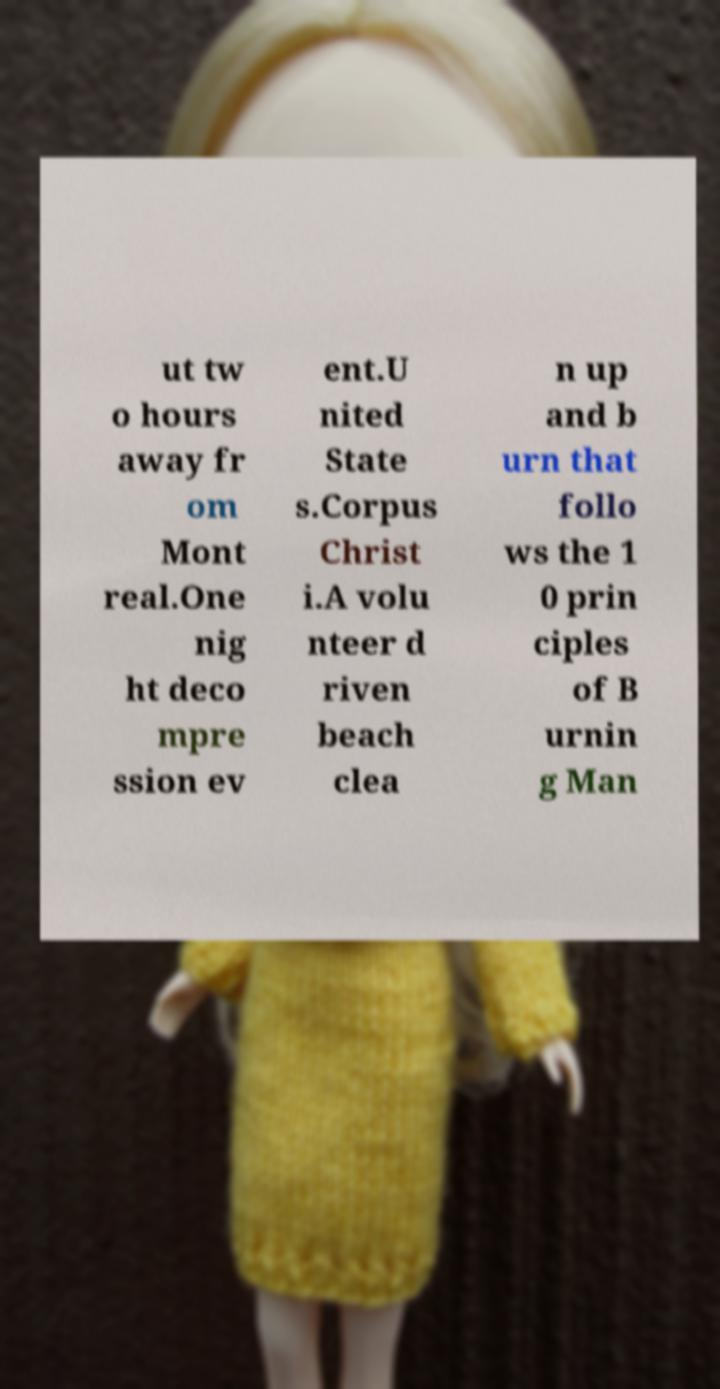I need the written content from this picture converted into text. Can you do that? ut tw o hours away fr om Mont real.One nig ht deco mpre ssion ev ent.U nited State s.Corpus Christ i.A volu nteer d riven beach clea n up and b urn that follo ws the 1 0 prin ciples of B urnin g Man 